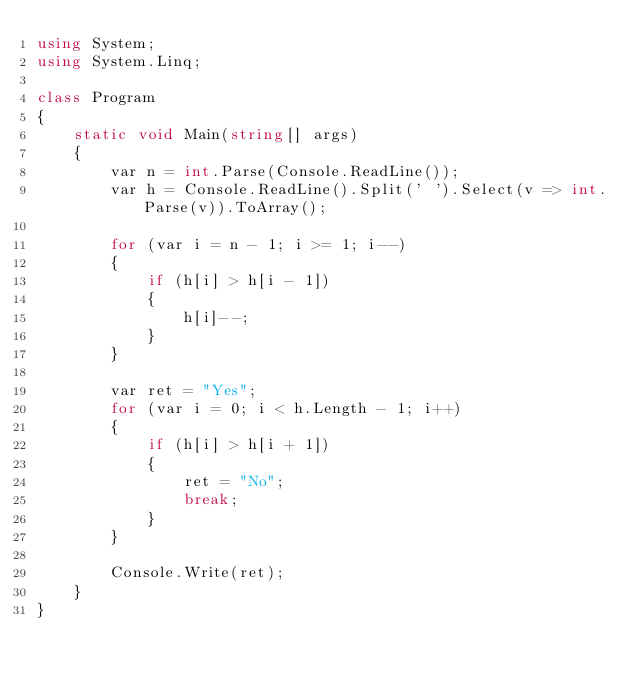Convert code to text. <code><loc_0><loc_0><loc_500><loc_500><_C#_>using System;
using System.Linq;

class Program
{
    static void Main(string[] args)
    {
        var n = int.Parse(Console.ReadLine());
        var h = Console.ReadLine().Split(' ').Select(v => int.Parse(v)).ToArray();
        
        for (var i = n - 1; i >= 1; i--)
        {
            if (h[i] > h[i - 1])
            {
                h[i]--;
            }
        }

        var ret = "Yes";
        for (var i = 0; i < h.Length - 1; i++)
        {
            if (h[i] > h[i + 1])
            {
                ret = "No";
                break;
            }
        }

        Console.Write(ret);
    }
}

</code> 